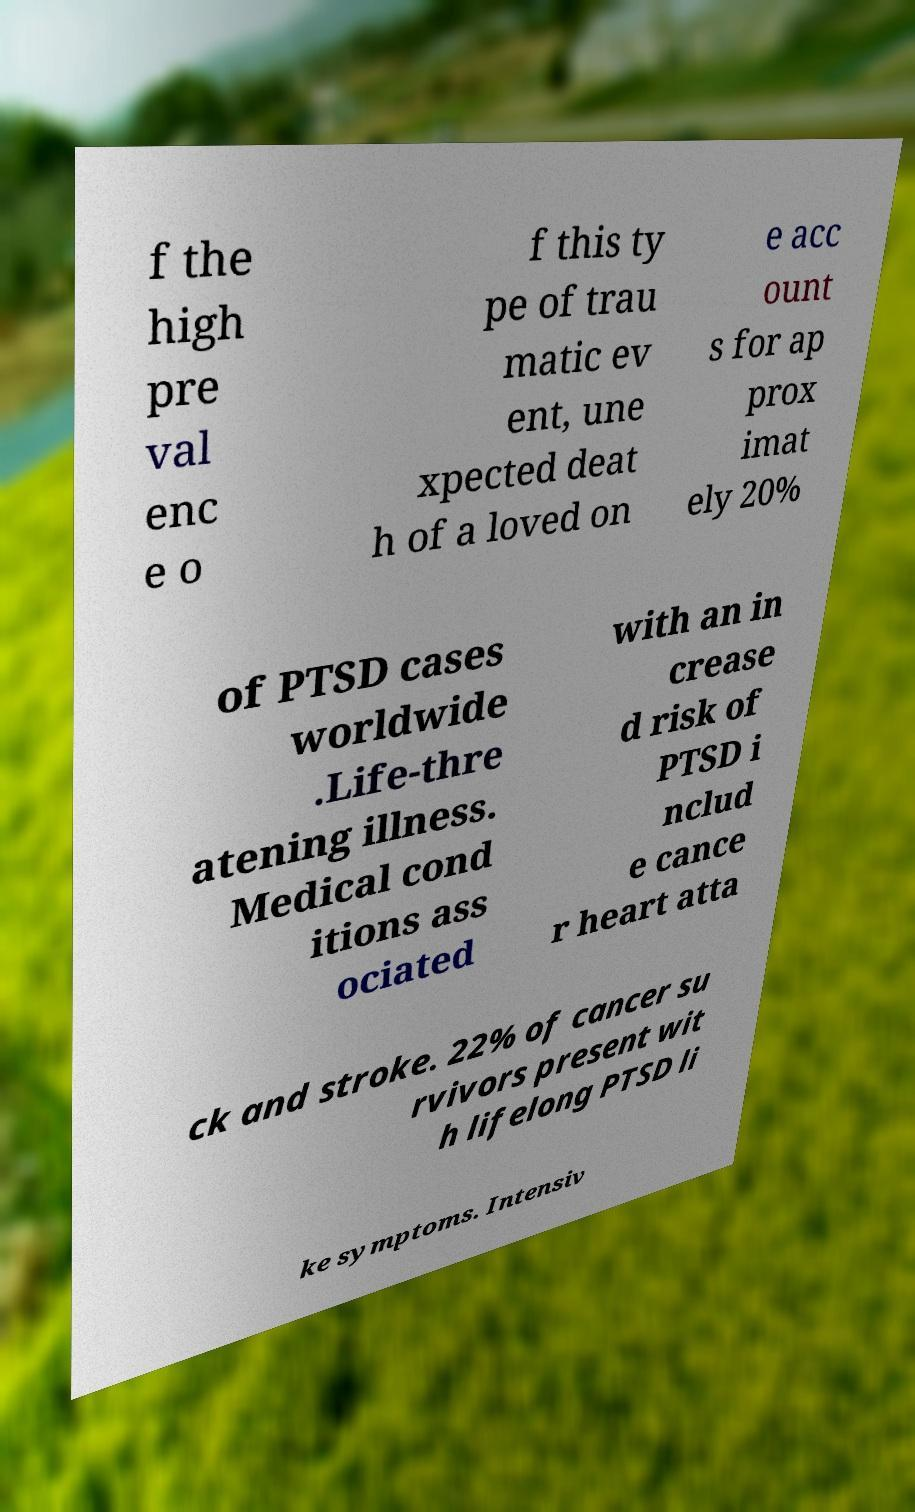I need the written content from this picture converted into text. Can you do that? f the high pre val enc e o f this ty pe of trau matic ev ent, une xpected deat h of a loved on e acc ount s for ap prox imat ely 20% of PTSD cases worldwide .Life-thre atening illness. Medical cond itions ass ociated with an in crease d risk of PTSD i nclud e cance r heart atta ck and stroke. 22% of cancer su rvivors present wit h lifelong PTSD li ke symptoms. Intensiv 